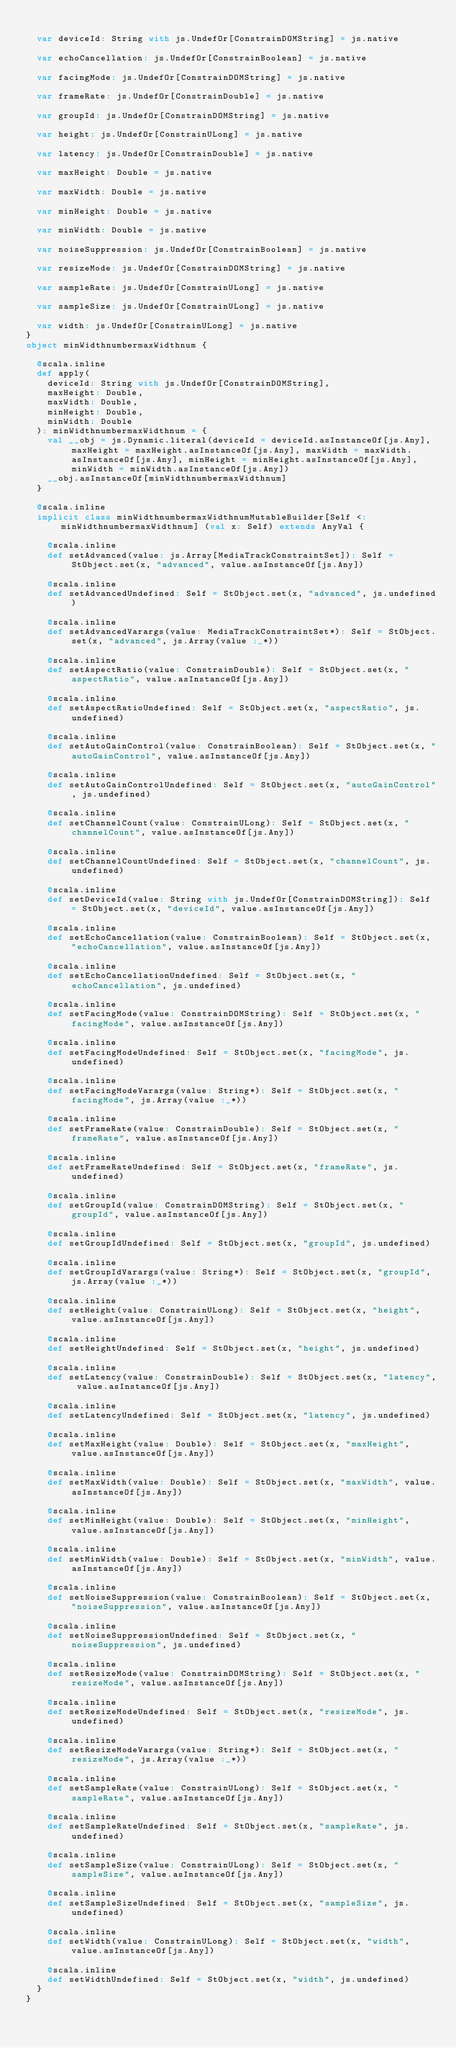Convert code to text. <code><loc_0><loc_0><loc_500><loc_500><_Scala_>  
  var deviceId: String with js.UndefOr[ConstrainDOMString] = js.native
  
  var echoCancellation: js.UndefOr[ConstrainBoolean] = js.native
  
  var facingMode: js.UndefOr[ConstrainDOMString] = js.native
  
  var frameRate: js.UndefOr[ConstrainDouble] = js.native
  
  var groupId: js.UndefOr[ConstrainDOMString] = js.native
  
  var height: js.UndefOr[ConstrainULong] = js.native
  
  var latency: js.UndefOr[ConstrainDouble] = js.native
  
  var maxHeight: Double = js.native
  
  var maxWidth: Double = js.native
  
  var minHeight: Double = js.native
  
  var minWidth: Double = js.native
  
  var noiseSuppression: js.UndefOr[ConstrainBoolean] = js.native
  
  var resizeMode: js.UndefOr[ConstrainDOMString] = js.native
  
  var sampleRate: js.UndefOr[ConstrainULong] = js.native
  
  var sampleSize: js.UndefOr[ConstrainULong] = js.native
  
  var width: js.UndefOr[ConstrainULong] = js.native
}
object minWidthnumbermaxWidthnum {
  
  @scala.inline
  def apply(
    deviceId: String with js.UndefOr[ConstrainDOMString],
    maxHeight: Double,
    maxWidth: Double,
    minHeight: Double,
    minWidth: Double
  ): minWidthnumbermaxWidthnum = {
    val __obj = js.Dynamic.literal(deviceId = deviceId.asInstanceOf[js.Any], maxHeight = maxHeight.asInstanceOf[js.Any], maxWidth = maxWidth.asInstanceOf[js.Any], minHeight = minHeight.asInstanceOf[js.Any], minWidth = minWidth.asInstanceOf[js.Any])
    __obj.asInstanceOf[minWidthnumbermaxWidthnum]
  }
  
  @scala.inline
  implicit class minWidthnumbermaxWidthnumMutableBuilder[Self <: minWidthnumbermaxWidthnum] (val x: Self) extends AnyVal {
    
    @scala.inline
    def setAdvanced(value: js.Array[MediaTrackConstraintSet]): Self = StObject.set(x, "advanced", value.asInstanceOf[js.Any])
    
    @scala.inline
    def setAdvancedUndefined: Self = StObject.set(x, "advanced", js.undefined)
    
    @scala.inline
    def setAdvancedVarargs(value: MediaTrackConstraintSet*): Self = StObject.set(x, "advanced", js.Array(value :_*))
    
    @scala.inline
    def setAspectRatio(value: ConstrainDouble): Self = StObject.set(x, "aspectRatio", value.asInstanceOf[js.Any])
    
    @scala.inline
    def setAspectRatioUndefined: Self = StObject.set(x, "aspectRatio", js.undefined)
    
    @scala.inline
    def setAutoGainControl(value: ConstrainBoolean): Self = StObject.set(x, "autoGainControl", value.asInstanceOf[js.Any])
    
    @scala.inline
    def setAutoGainControlUndefined: Self = StObject.set(x, "autoGainControl", js.undefined)
    
    @scala.inline
    def setChannelCount(value: ConstrainULong): Self = StObject.set(x, "channelCount", value.asInstanceOf[js.Any])
    
    @scala.inline
    def setChannelCountUndefined: Self = StObject.set(x, "channelCount", js.undefined)
    
    @scala.inline
    def setDeviceId(value: String with js.UndefOr[ConstrainDOMString]): Self = StObject.set(x, "deviceId", value.asInstanceOf[js.Any])
    
    @scala.inline
    def setEchoCancellation(value: ConstrainBoolean): Self = StObject.set(x, "echoCancellation", value.asInstanceOf[js.Any])
    
    @scala.inline
    def setEchoCancellationUndefined: Self = StObject.set(x, "echoCancellation", js.undefined)
    
    @scala.inline
    def setFacingMode(value: ConstrainDOMString): Self = StObject.set(x, "facingMode", value.asInstanceOf[js.Any])
    
    @scala.inline
    def setFacingModeUndefined: Self = StObject.set(x, "facingMode", js.undefined)
    
    @scala.inline
    def setFacingModeVarargs(value: String*): Self = StObject.set(x, "facingMode", js.Array(value :_*))
    
    @scala.inline
    def setFrameRate(value: ConstrainDouble): Self = StObject.set(x, "frameRate", value.asInstanceOf[js.Any])
    
    @scala.inline
    def setFrameRateUndefined: Self = StObject.set(x, "frameRate", js.undefined)
    
    @scala.inline
    def setGroupId(value: ConstrainDOMString): Self = StObject.set(x, "groupId", value.asInstanceOf[js.Any])
    
    @scala.inline
    def setGroupIdUndefined: Self = StObject.set(x, "groupId", js.undefined)
    
    @scala.inline
    def setGroupIdVarargs(value: String*): Self = StObject.set(x, "groupId", js.Array(value :_*))
    
    @scala.inline
    def setHeight(value: ConstrainULong): Self = StObject.set(x, "height", value.asInstanceOf[js.Any])
    
    @scala.inline
    def setHeightUndefined: Self = StObject.set(x, "height", js.undefined)
    
    @scala.inline
    def setLatency(value: ConstrainDouble): Self = StObject.set(x, "latency", value.asInstanceOf[js.Any])
    
    @scala.inline
    def setLatencyUndefined: Self = StObject.set(x, "latency", js.undefined)
    
    @scala.inline
    def setMaxHeight(value: Double): Self = StObject.set(x, "maxHeight", value.asInstanceOf[js.Any])
    
    @scala.inline
    def setMaxWidth(value: Double): Self = StObject.set(x, "maxWidth", value.asInstanceOf[js.Any])
    
    @scala.inline
    def setMinHeight(value: Double): Self = StObject.set(x, "minHeight", value.asInstanceOf[js.Any])
    
    @scala.inline
    def setMinWidth(value: Double): Self = StObject.set(x, "minWidth", value.asInstanceOf[js.Any])
    
    @scala.inline
    def setNoiseSuppression(value: ConstrainBoolean): Self = StObject.set(x, "noiseSuppression", value.asInstanceOf[js.Any])
    
    @scala.inline
    def setNoiseSuppressionUndefined: Self = StObject.set(x, "noiseSuppression", js.undefined)
    
    @scala.inline
    def setResizeMode(value: ConstrainDOMString): Self = StObject.set(x, "resizeMode", value.asInstanceOf[js.Any])
    
    @scala.inline
    def setResizeModeUndefined: Self = StObject.set(x, "resizeMode", js.undefined)
    
    @scala.inline
    def setResizeModeVarargs(value: String*): Self = StObject.set(x, "resizeMode", js.Array(value :_*))
    
    @scala.inline
    def setSampleRate(value: ConstrainULong): Self = StObject.set(x, "sampleRate", value.asInstanceOf[js.Any])
    
    @scala.inline
    def setSampleRateUndefined: Self = StObject.set(x, "sampleRate", js.undefined)
    
    @scala.inline
    def setSampleSize(value: ConstrainULong): Self = StObject.set(x, "sampleSize", value.asInstanceOf[js.Any])
    
    @scala.inline
    def setSampleSizeUndefined: Self = StObject.set(x, "sampleSize", js.undefined)
    
    @scala.inline
    def setWidth(value: ConstrainULong): Self = StObject.set(x, "width", value.asInstanceOf[js.Any])
    
    @scala.inline
    def setWidthUndefined: Self = StObject.set(x, "width", js.undefined)
  }
}
</code> 